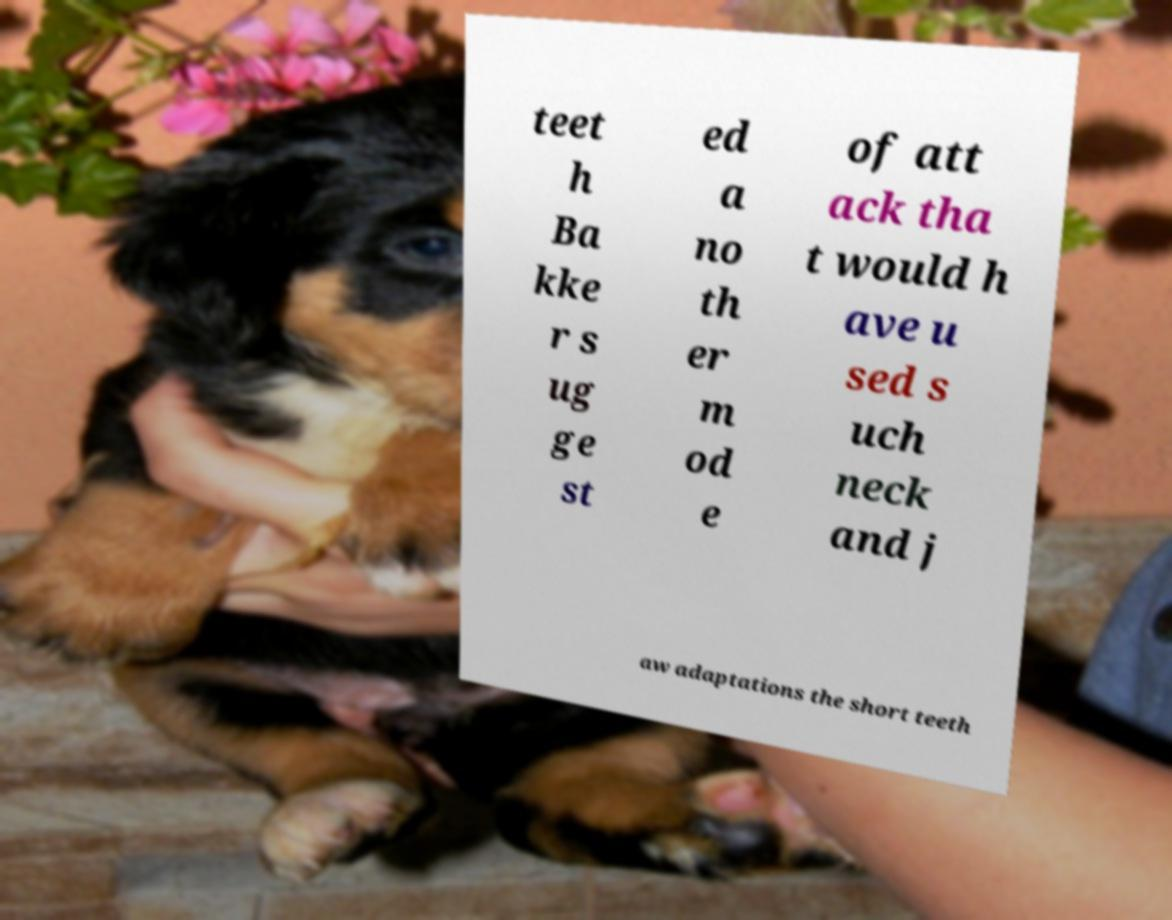For documentation purposes, I need the text within this image transcribed. Could you provide that? teet h Ba kke r s ug ge st ed a no th er m od e of att ack tha t would h ave u sed s uch neck and j aw adaptations the short teeth 